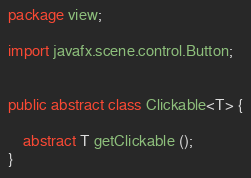<code> <loc_0><loc_0><loc_500><loc_500><_Java_>package view;

import javafx.scene.control.Button;


public abstract class Clickable<T> {

    abstract T getClickable ();
}
</code> 